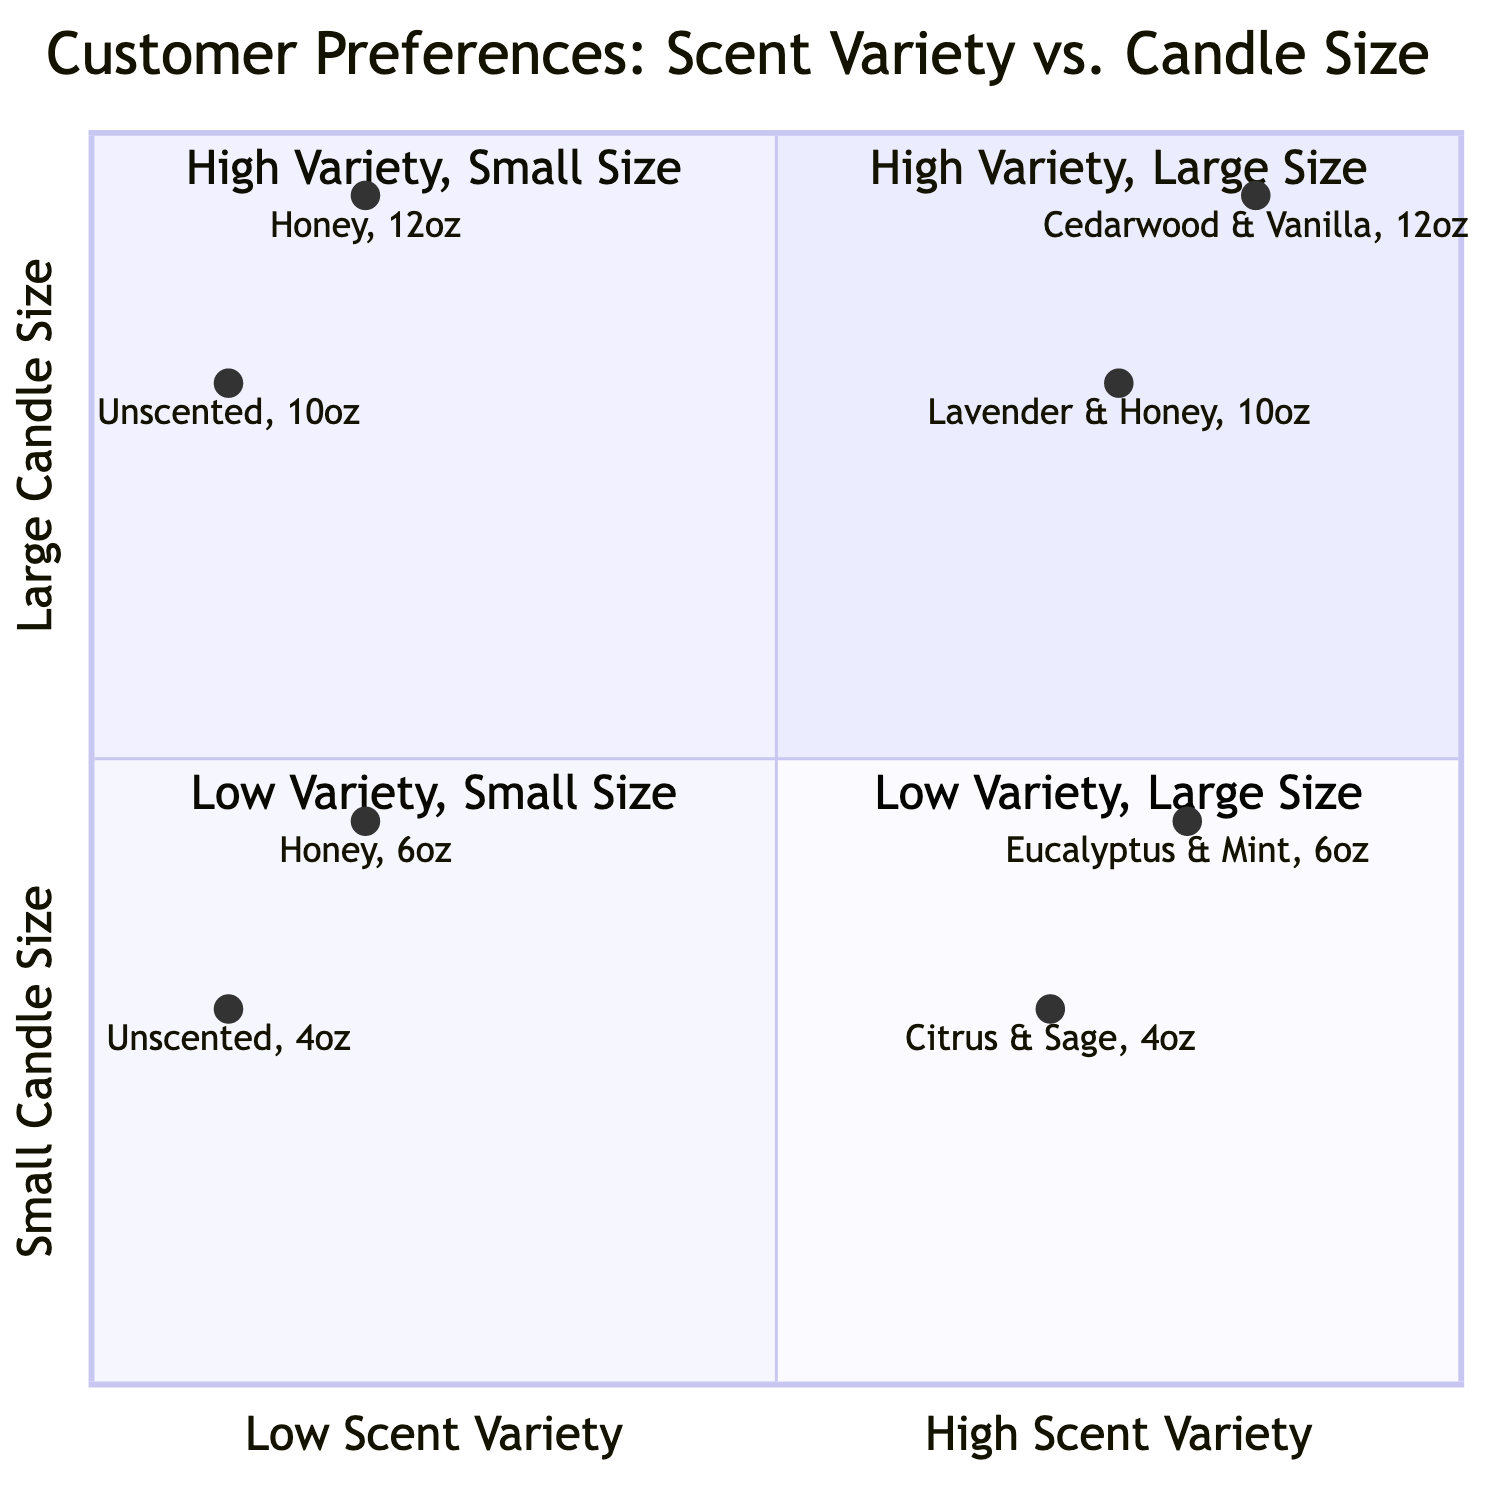What is the largest candle size represented in the diagram? The largest candle size is found by examining the 'Candle Size' values in the quadrants. The largest candle size listed in the examples is 12 oz, which appears in quadrant 1 and quadrant 4.
Answer: 12 oz Which scents fall under high scent variety and small candle size? To answer this, we look at quadrant 2 which describes "High Scent Variety + Small Candle Size." The examples here are "Citrus & Sage" and "Eucalyptus & Mint."
Answer: Citrus & Sage, Eucalyptus & Mint How many examples are in the low scent variety and large candle size quadrant? Focusing on quadrant 4, which is "Low Scent Variety + Large Candle Size," we can identify the examples listed: "Unscented, 10 oz" and "Honey, 12 oz." This gives us a total of 2 examples.
Answer: 2 What is the description of quadrant 1? The description of quadrant 1 can be found in the data provided, identifying it as "High Scent Variety + Large Candle Size." This quadrant focuses on larger candles that offer a variety of scents.
Answer: High Scent Variety + Large Candle Size Which scent corresponds to the smallest candle size in the diagram? By examining all the examples across the quadrants, we find that the smallest candle size mentioned is 4 oz, associated with scents "Citrus & Sage" and "Unscented."
Answer: Unscented What are the sizes of the scents in quadrant 3? Quadrant 3 is described as "Low Scent Variety + Small Candle Size." The examples here are "Unscented" and "Honey," both of which have sizes of 4 oz and 6 oz, respectively.
Answer: 4 oz, 6 oz How many scents are listed in the high variety, large size quadrant? In quadrant 1, which represents "High Scent Variety + Large Candle Size," there are two scents listed: "Lavender & Honey" and "Cedarwood & Vanilla." Thus, the count is 2.
Answer: 2 What is the primary difference between quadrants 2 and 4? Quadrant 2 focuses on "High Scent Variety + Small Candle Size," while quadrant 4 is about "Low Scent Variety + Large Candle Size." This indicates a shift in both scent variety and candle size between the two quadrants.
Answer: Scent variety and size Which scent is categorized in low variety and small size? The scents that fall under low scent variety and small candle size belong to quadrant 3, which includes "Unscented" and "Honey."
Answer: Unscented, Honey 